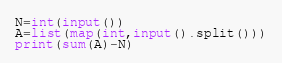<code> <loc_0><loc_0><loc_500><loc_500><_Python_>N=int(input())
A=list(map(int,input().split()))
print(sum(A)-N)</code> 